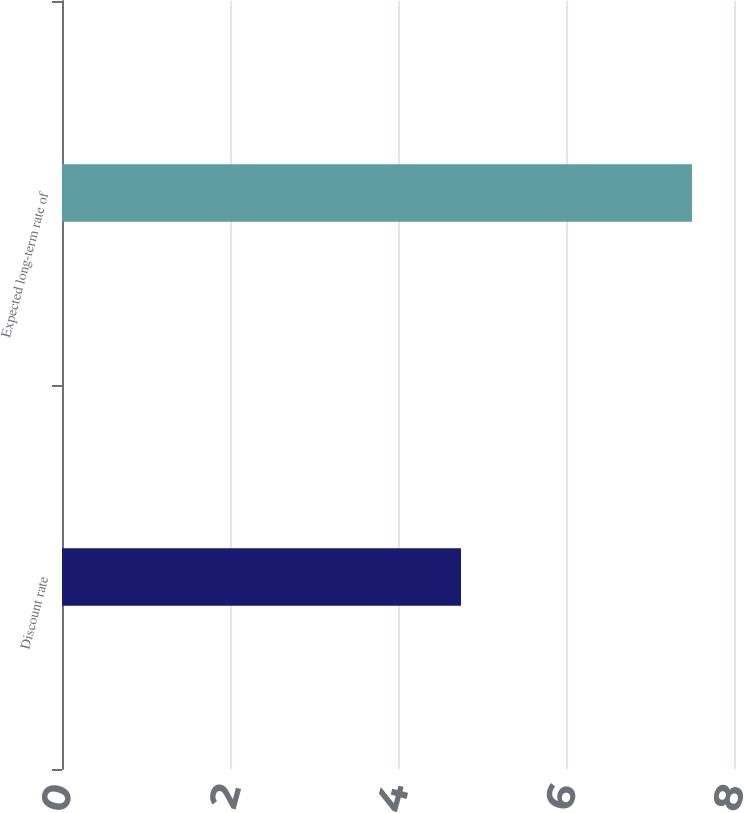Convert chart to OTSL. <chart><loc_0><loc_0><loc_500><loc_500><bar_chart><fcel>Discount rate<fcel>Expected long-term rate of<nl><fcel>4.75<fcel>7.5<nl></chart> 